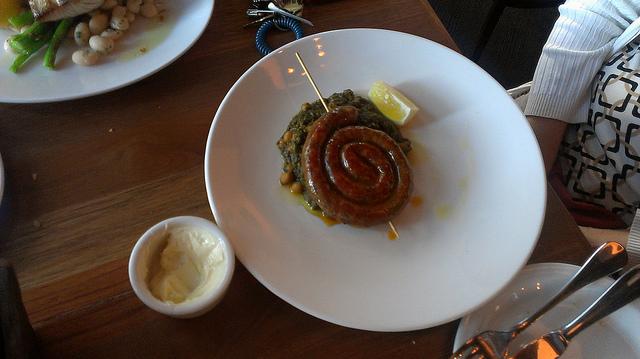What shape is the plate?
Keep it brief. Round. How many utensils are visible?
Concise answer only. 2. What is in a spiral on the plate?
Concise answer only. Sausage. Is this a pancake?
Short answer required. No. 